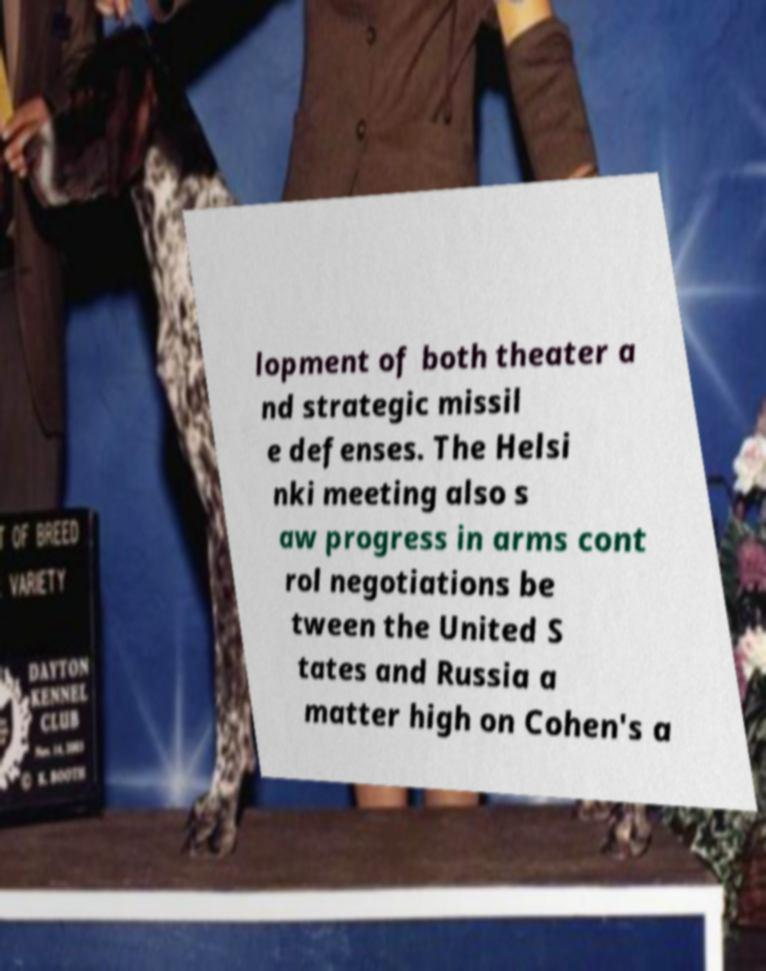There's text embedded in this image that I need extracted. Can you transcribe it verbatim? lopment of both theater a nd strategic missil e defenses. The Helsi nki meeting also s aw progress in arms cont rol negotiations be tween the United S tates and Russia a matter high on Cohen's a 